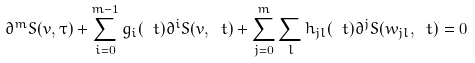Convert formula to latex. <formula><loc_0><loc_0><loc_500><loc_500>\partial ^ { m } S ( v , \tau ) + \sum _ { i = 0 } ^ { m - 1 } g _ { i } ( \ t ) \partial ^ { i } S ( v , \ t ) + \sum _ { j = 0 } ^ { m } \sum _ { l } h _ { j l } ( \ t ) \partial ^ { j } S ( w _ { j l } , \ t ) = 0</formula> 